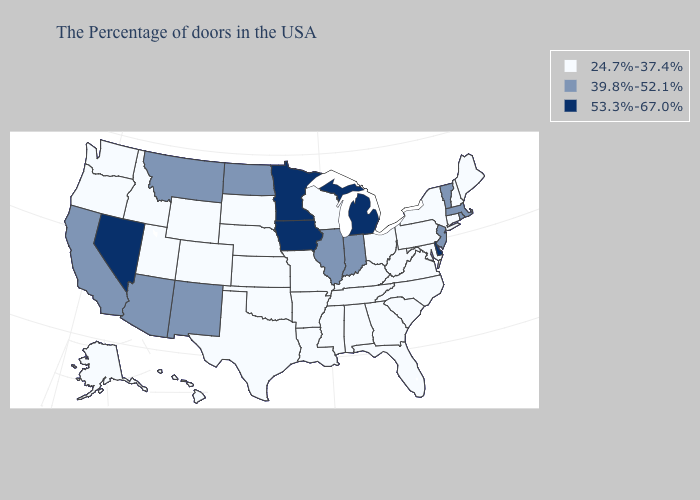Which states hav the highest value in the South?
Be succinct. Delaware. Name the states that have a value in the range 39.8%-52.1%?
Be succinct. Massachusetts, Rhode Island, Vermont, New Jersey, Indiana, Illinois, North Dakota, New Mexico, Montana, Arizona, California. Name the states that have a value in the range 39.8%-52.1%?
Give a very brief answer. Massachusetts, Rhode Island, Vermont, New Jersey, Indiana, Illinois, North Dakota, New Mexico, Montana, Arizona, California. What is the value of Kansas?
Give a very brief answer. 24.7%-37.4%. What is the value of New York?
Short answer required. 24.7%-37.4%. What is the lowest value in states that border Arizona?
Write a very short answer. 24.7%-37.4%. What is the value of Alaska?
Be succinct. 24.7%-37.4%. What is the value of Alaska?
Quick response, please. 24.7%-37.4%. Among the states that border Georgia , which have the lowest value?
Quick response, please. North Carolina, South Carolina, Florida, Alabama, Tennessee. Does Delaware have the lowest value in the South?
Concise answer only. No. Name the states that have a value in the range 39.8%-52.1%?
Answer briefly. Massachusetts, Rhode Island, Vermont, New Jersey, Indiana, Illinois, North Dakota, New Mexico, Montana, Arizona, California. Which states hav the highest value in the South?
Short answer required. Delaware. What is the value of Wyoming?
Be succinct. 24.7%-37.4%. What is the lowest value in the West?
Quick response, please. 24.7%-37.4%. Does Wyoming have a higher value than Maine?
Give a very brief answer. No. 